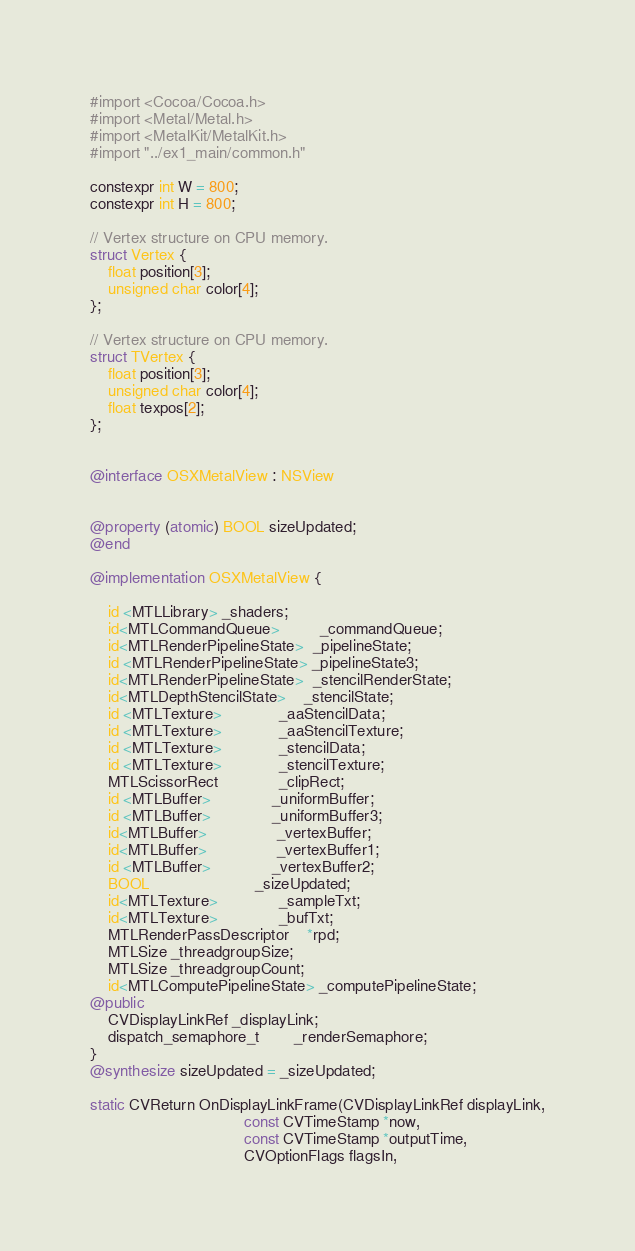<code> <loc_0><loc_0><loc_500><loc_500><_ObjectiveC_>#import <Cocoa/Cocoa.h>
#import <Metal/Metal.h>
#import <MetalKit/MetalKit.h>
#import "../ex1_main/common.h"

constexpr int W = 800;
constexpr int H = 800;

// Vertex structure on CPU memory.
struct Vertex {
    float position[3];
    unsigned char color[4];
};

// Vertex structure on CPU memory.
struct TVertex {
    float position[3];
    unsigned char color[4];
    float texpos[2];
};


@interface OSXMetalView : NSView


@property (atomic) BOOL sizeUpdated;
@end

@implementation OSXMetalView {

    id <MTLLibrary> _shaders;
    id<MTLCommandQueue>         _commandQueue;
    id<MTLRenderPipelineState>  _pipelineState;
    id <MTLRenderPipelineState> _pipelineState3;
    id<MTLRenderPipelineState>  _stencilRenderState;
    id<MTLDepthStencilState>    _stencilState;
    id <MTLTexture>             _aaStencilData;
    id <MTLTexture>             _aaStencilTexture;
    id <MTLTexture>             _stencilData;
    id <MTLTexture>             _stencilTexture;
    MTLScissorRect              _clipRect;
    id <MTLBuffer>              _uniformBuffer;
    id <MTLBuffer>              _uniformBuffer3;
    id<MTLBuffer>  			    _vertexBuffer;
    id<MTLBuffer>  			    _vertexBuffer1;
    id <MTLBuffer>              _vertexBuffer2;
    BOOL 				        _sizeUpdated;
    id<MTLTexture>              _sampleTxt;
    id<MTLTexture>              _bufTxt;
    MTLRenderPassDescriptor    *rpd;
    MTLSize _threadgroupSize;
    MTLSize _threadgroupCount;
    id<MTLComputePipelineState> _computePipelineState;
@public
    CVDisplayLinkRef _displayLink;
    dispatch_semaphore_t 	    _renderSemaphore;
}
@synthesize sizeUpdated = _sizeUpdated;

static CVReturn OnDisplayLinkFrame(CVDisplayLinkRef displayLink,
                                   const CVTimeStamp *now,
                                   const CVTimeStamp *outputTime,
                                   CVOptionFlags flagsIn,</code> 